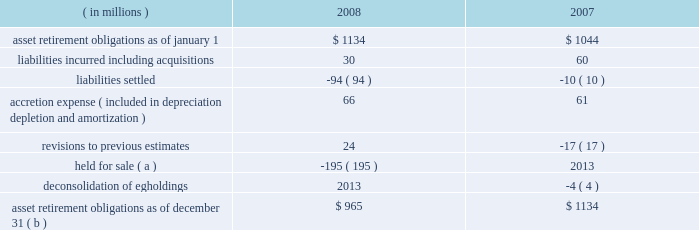Marathon oil corporation notes to consolidated financial statements ( f ) this sale-leaseback financing arrangement relates to a lease of a slab caster at united states steel 2019s fairfield works facility in alabama .
We are the primary obligor under this lease .
Under the financial matters agreement , united states steel has assumed responsibility for all obligations under this lease .
This lease is an amortizing financing with a final maturity of 2012 , subject to additional extensions .
( g ) this obligation relates to a lease of equipment at united states steel 2019s clairton works cokemaking facility in pennsylvania .
We are the primary obligor under this lease .
Under the financial matters agreement , united states steel has assumed responsibility for all obligations under this lease .
This lease is an amortizing financing with a final maturity of 2012 .
( h ) marathon oil canada corporation had an 805 million canadian dollar revolving term credit facility which was secured by substantially all of marathon oil canada corporation 2019s assets and included certain financial covenants , including leverage and interest coverage ratios .
In february 2008 , the outstanding balance was repaid and the facility was terminated .
( i ) these notes are senior secured notes of marathon oil canada corporation .
The notes were secured by substantially all of marathon oil canada corporation 2019s assets .
In january 2008 , we provided a full and unconditional guarantee covering the payment of all principal and interest due under the senior notes .
( j ) these obligations as of december 31 , 2008 include $ 126 million related to assets under construction at that date for which capital leases or sale-leaseback financings will commence upon completion of construction .
The amounts currently reported are based upon the percent of construction completed as of december 31 , 2008 and therefore do not reflect future minimum lease obligations of $ 209 million .
( k ) payments of long-term debt for the years 2009 2013 2013 are $ 99 million , $ 98 million , $ 257 million , $ 1487 million and $ 279 million .
Of these amounts , payments assumed by united states steel are $ 15 million , $ 17 million , $ 161 million , $ 19 million and zero .
( l ) in the event of a change in control , as defined in the related agreements , debt obligations totaling $ 669 million at december 31 , 2008 , may be declared immediately due and payable .
( m ) see note 17 for information on interest rate swaps .
On february 17 , 2009 , we issued $ 700 million aggregate principal amount of senior notes bearing interest at 6.5 percent with a maturity date of february 15 , 2014 and $ 800 million aggregate principal amount of senior notes bearing interest at 7.5 percent with a maturity date of february 15 , 2019 .
Interest on both issues is payable semi- annually beginning august 15 , 2009 .
21 .
Asset retirement obligations the following summarizes the changes in asset retirement obligations : ( in millions ) 2008 2007 .
Asset retirement obligations as of december 31 ( b ) $ 965 $ 1134 ( a ) see note 7 for information related to our assets held for sale .
( b ) includes asset retirement obligation of $ 2 and $ 3 million classified as short-term at december 31 , 2008 , and 2007. .
By how much did asset retirement obligations decrease from 2007 to 2008? 
Computations: ((965 - 1134) / 1134)
Answer: -0.14903. 